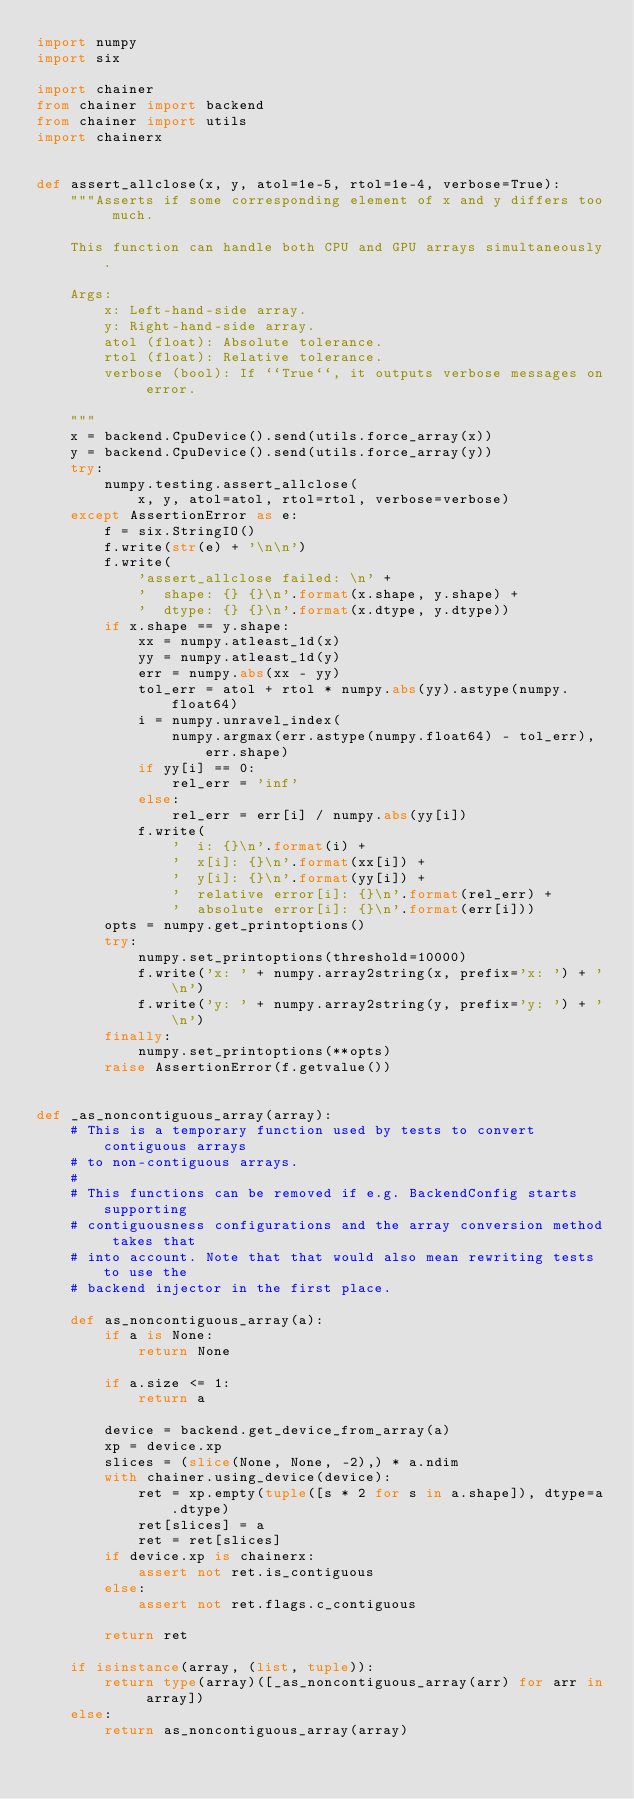<code> <loc_0><loc_0><loc_500><loc_500><_Python_>import numpy
import six

import chainer
from chainer import backend
from chainer import utils
import chainerx


def assert_allclose(x, y, atol=1e-5, rtol=1e-4, verbose=True):
    """Asserts if some corresponding element of x and y differs too much.

    This function can handle both CPU and GPU arrays simultaneously.

    Args:
        x: Left-hand-side array.
        y: Right-hand-side array.
        atol (float): Absolute tolerance.
        rtol (float): Relative tolerance.
        verbose (bool): If ``True``, it outputs verbose messages on error.

    """
    x = backend.CpuDevice().send(utils.force_array(x))
    y = backend.CpuDevice().send(utils.force_array(y))
    try:
        numpy.testing.assert_allclose(
            x, y, atol=atol, rtol=rtol, verbose=verbose)
    except AssertionError as e:
        f = six.StringIO()
        f.write(str(e) + '\n\n')
        f.write(
            'assert_allclose failed: \n' +
            '  shape: {} {}\n'.format(x.shape, y.shape) +
            '  dtype: {} {}\n'.format(x.dtype, y.dtype))
        if x.shape == y.shape:
            xx = numpy.atleast_1d(x)
            yy = numpy.atleast_1d(y)
            err = numpy.abs(xx - yy)
            tol_err = atol + rtol * numpy.abs(yy).astype(numpy.float64)
            i = numpy.unravel_index(
                numpy.argmax(err.astype(numpy.float64) - tol_err), err.shape)
            if yy[i] == 0:
                rel_err = 'inf'
            else:
                rel_err = err[i] / numpy.abs(yy[i])
            f.write(
                '  i: {}\n'.format(i) +
                '  x[i]: {}\n'.format(xx[i]) +
                '  y[i]: {}\n'.format(yy[i]) +
                '  relative error[i]: {}\n'.format(rel_err) +
                '  absolute error[i]: {}\n'.format(err[i]))
        opts = numpy.get_printoptions()
        try:
            numpy.set_printoptions(threshold=10000)
            f.write('x: ' + numpy.array2string(x, prefix='x: ') + '\n')
            f.write('y: ' + numpy.array2string(y, prefix='y: ') + '\n')
        finally:
            numpy.set_printoptions(**opts)
        raise AssertionError(f.getvalue())


def _as_noncontiguous_array(array):
    # This is a temporary function used by tests to convert contiguous arrays
    # to non-contiguous arrays.
    #
    # This functions can be removed if e.g. BackendConfig starts supporting
    # contiguousness configurations and the array conversion method takes that
    # into account. Note that that would also mean rewriting tests to use the
    # backend injector in the first place.

    def as_noncontiguous_array(a):
        if a is None:
            return None

        if a.size <= 1:
            return a

        device = backend.get_device_from_array(a)
        xp = device.xp
        slices = (slice(None, None, -2),) * a.ndim
        with chainer.using_device(device):
            ret = xp.empty(tuple([s * 2 for s in a.shape]), dtype=a.dtype)
            ret[slices] = a
            ret = ret[slices]
        if device.xp is chainerx:
            assert not ret.is_contiguous
        else:
            assert not ret.flags.c_contiguous

        return ret

    if isinstance(array, (list, tuple)):
        return type(array)([_as_noncontiguous_array(arr) for arr in array])
    else:
        return as_noncontiguous_array(array)
</code> 